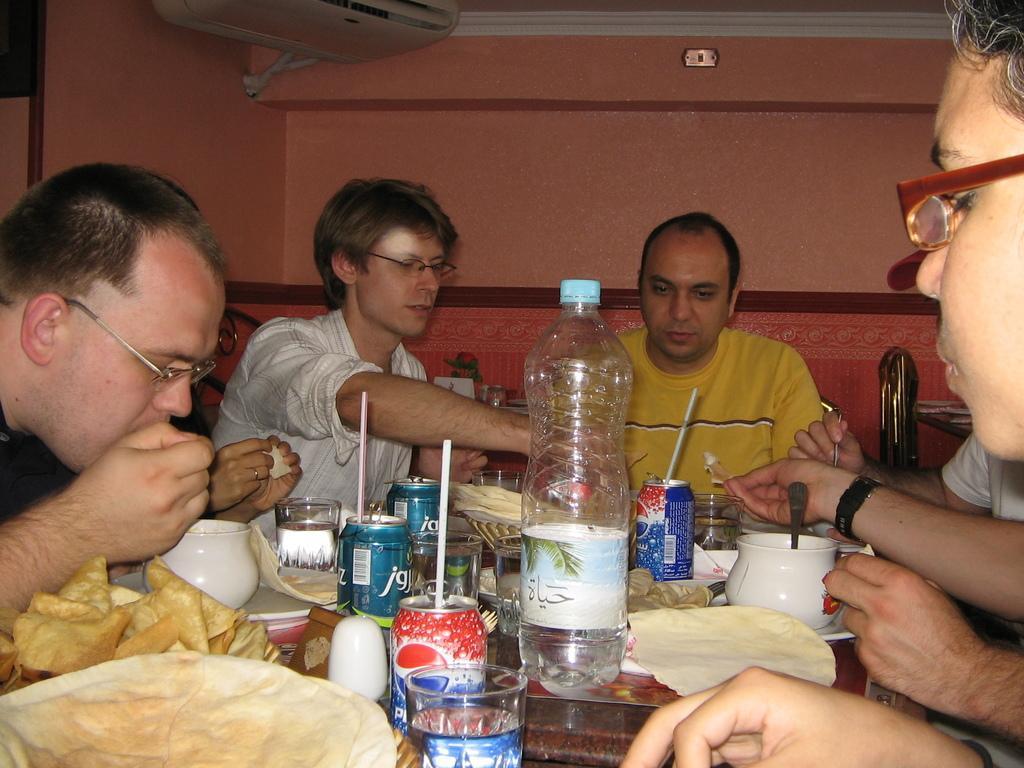Describe this image in one or two sentences. In this image I can see group of people sitting in front of the table. Among them one person is wearing the yellow t-shirt. On the table there are tins,bottle,spoons,cups,glasses and the food. In the back there is a brown color wall and the air conditioner. 